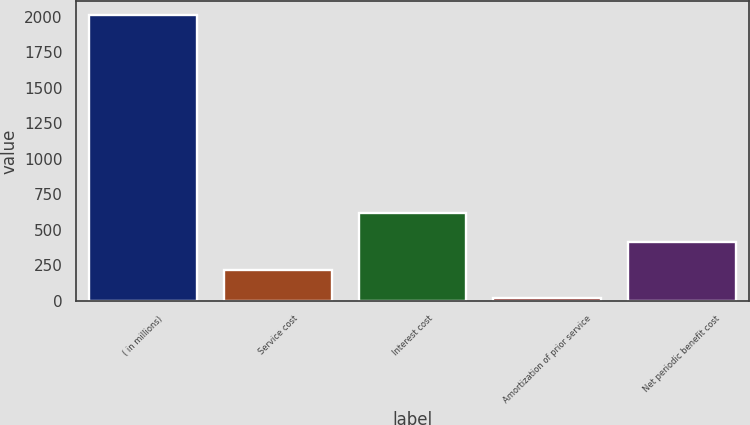Convert chart to OTSL. <chart><loc_0><loc_0><loc_500><loc_500><bar_chart><fcel>( in millions)<fcel>Service cost<fcel>Interest cost<fcel>Amortization of prior service<fcel>Net periodic benefit cost<nl><fcel>2013<fcel>217.5<fcel>616.5<fcel>18<fcel>417<nl></chart> 